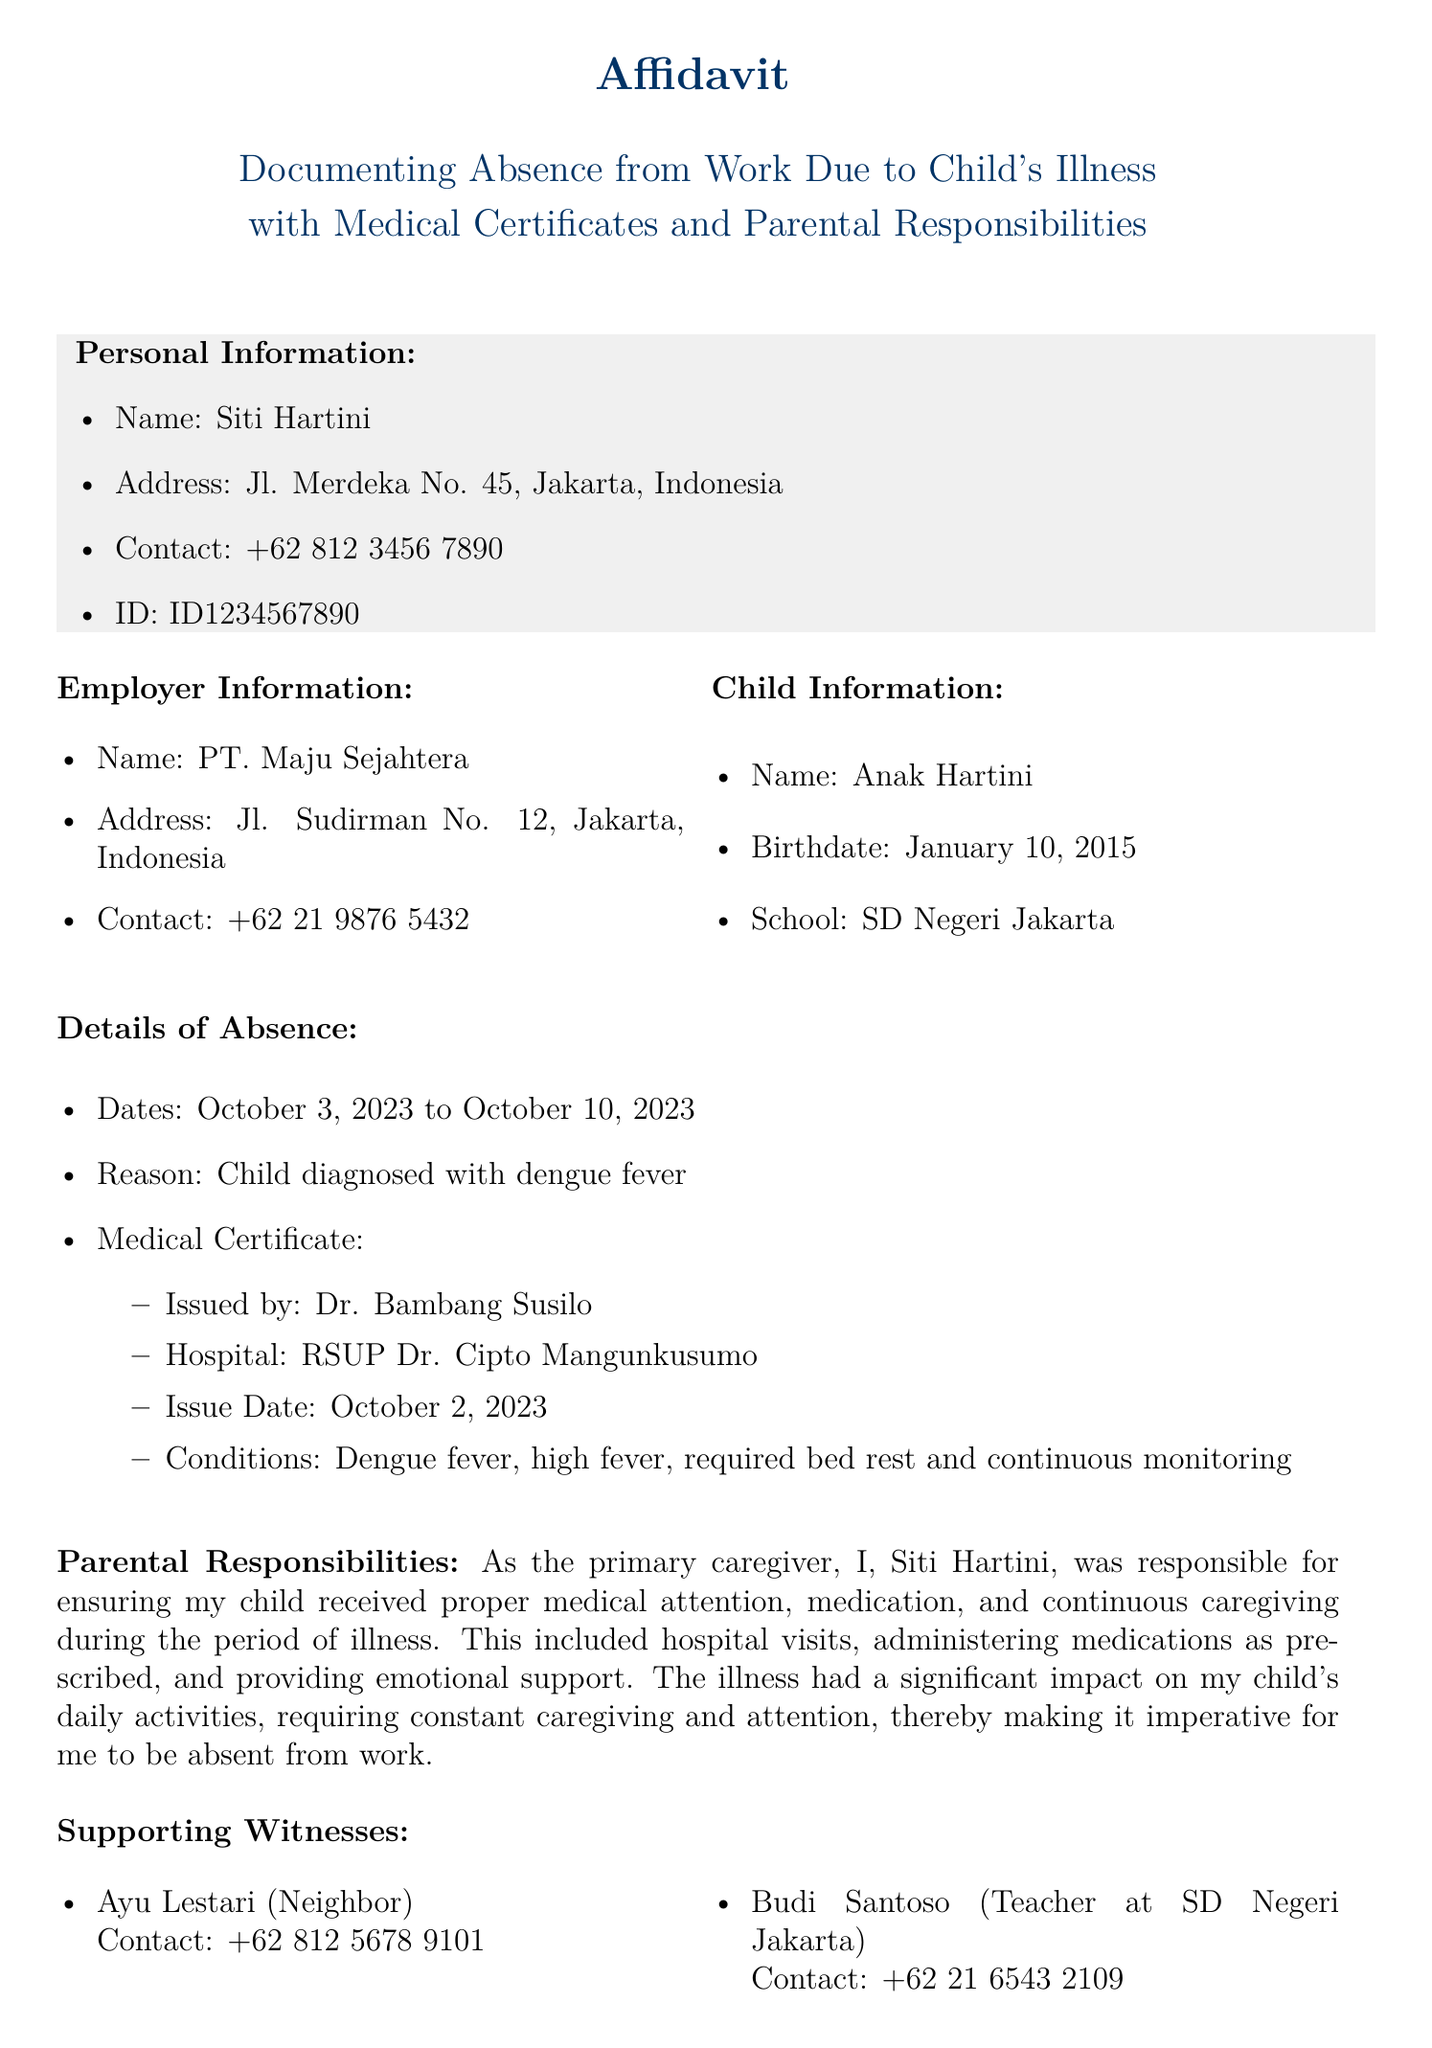What is the full name of the person making the affidavit? The name listed in the personal information section of the document is Siti Hartini.
Answer: Siti Hartini What is the birthdate of Siti Hartini's child? The document provides the child’s birthdate as January 10, 2015.
Answer: January 10, 2015 What is the reason for absence from work? The document states that the absence was due to the child diagnosed with dengue fever.
Answer: Dengue fever Who issued the medical certificate? The medical certificate was issued by Dr. Bambang Susilo, as mentioned in the details of absence.
Answer: Dr. Bambang Susilo What were the dates of absence? The document specifies the absence occurred from October 3, 2023 to October 10, 2023.
Answer: October 3, 2023 to October 10, 2023 What is included in the parental responsibilities? The document mentions ensuring proper medical attention, medication, and continuous caregiving.
Answer: Medical attention, medication, caregiving How many witnesses are mentioned in the affidavit? The document lists two witnesses who supported the affidavit.
Answer: Two witnesses What is the declaration made by Siti Hartini? Siti Hartini declares that the information provided in the affidavit is true and correct.
Answer: True and correct What is the date of the affidavit signing? The affidavit is signed on October 11, 2023, which is noted at the bottom.
Answer: October 11, 2023 